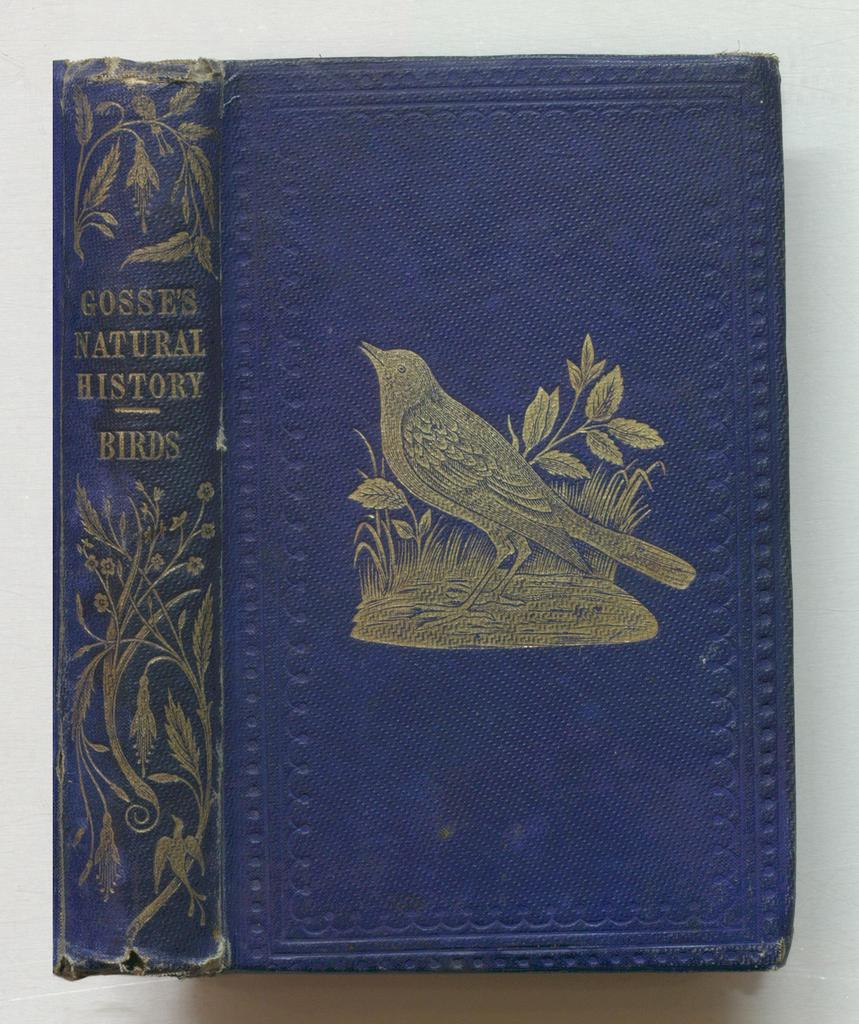<image>
Write a terse but informative summary of the picture. The front cover and spine of a book about birds. 